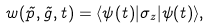Convert formula to latex. <formula><loc_0><loc_0><loc_500><loc_500>w ( \vec { p } , \vec { g } , t ) = \langle \psi ( t ) | \sigma _ { z } | \psi ( t ) \rangle ,</formula> 